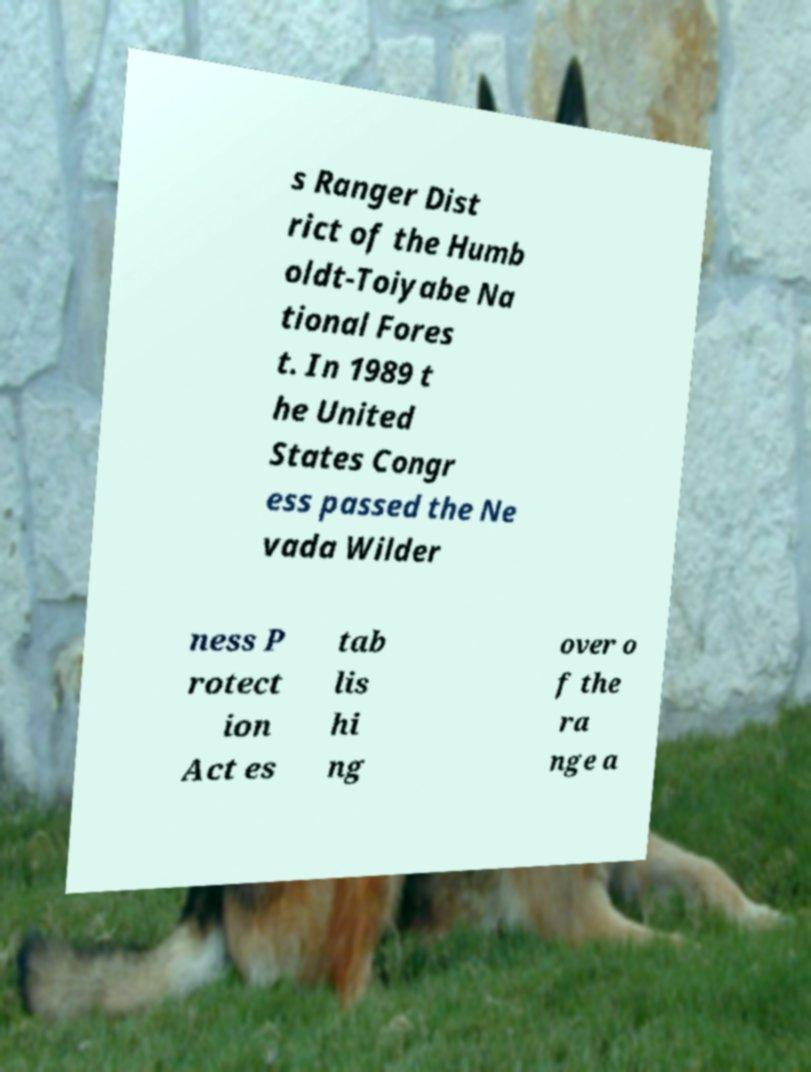What messages or text are displayed in this image? I need them in a readable, typed format. s Ranger Dist rict of the Humb oldt-Toiyabe Na tional Fores t. In 1989 t he United States Congr ess passed the Ne vada Wilder ness P rotect ion Act es tab lis hi ng over o f the ra nge a 